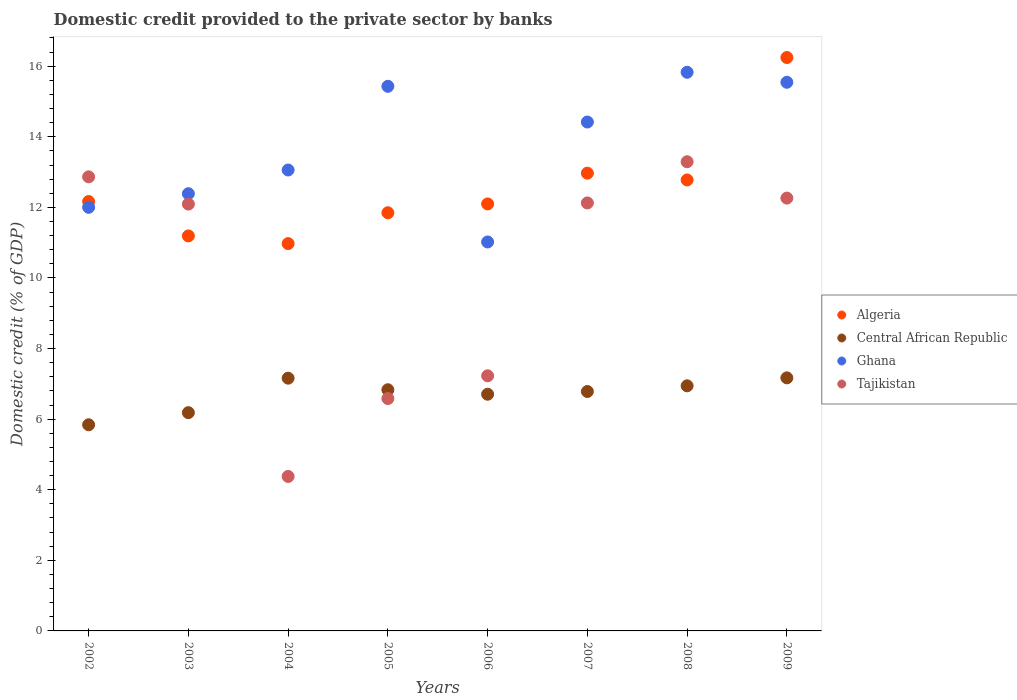What is the domestic credit provided to the private sector by banks in Algeria in 2004?
Make the answer very short. 10.97. Across all years, what is the maximum domestic credit provided to the private sector by banks in Ghana?
Your response must be concise. 15.83. Across all years, what is the minimum domestic credit provided to the private sector by banks in Tajikistan?
Your answer should be very brief. 4.38. In which year was the domestic credit provided to the private sector by banks in Algeria maximum?
Your response must be concise. 2009. In which year was the domestic credit provided to the private sector by banks in Algeria minimum?
Provide a succinct answer. 2004. What is the total domestic credit provided to the private sector by banks in Tajikistan in the graph?
Offer a terse response. 80.83. What is the difference between the domestic credit provided to the private sector by banks in Ghana in 2002 and that in 2005?
Make the answer very short. -3.43. What is the difference between the domestic credit provided to the private sector by banks in Central African Republic in 2004 and the domestic credit provided to the private sector by banks in Algeria in 2005?
Keep it short and to the point. -4.69. What is the average domestic credit provided to the private sector by banks in Algeria per year?
Offer a terse response. 12.53. In the year 2002, what is the difference between the domestic credit provided to the private sector by banks in Tajikistan and domestic credit provided to the private sector by banks in Central African Republic?
Ensure brevity in your answer.  7.02. In how many years, is the domestic credit provided to the private sector by banks in Algeria greater than 14.4 %?
Make the answer very short. 1. What is the ratio of the domestic credit provided to the private sector by banks in Tajikistan in 2007 to that in 2009?
Provide a short and direct response. 0.99. Is the difference between the domestic credit provided to the private sector by banks in Tajikistan in 2005 and 2008 greater than the difference between the domestic credit provided to the private sector by banks in Central African Republic in 2005 and 2008?
Offer a very short reply. No. What is the difference between the highest and the second highest domestic credit provided to the private sector by banks in Algeria?
Make the answer very short. 3.28. What is the difference between the highest and the lowest domestic credit provided to the private sector by banks in Ghana?
Your answer should be compact. 4.81. Is it the case that in every year, the sum of the domestic credit provided to the private sector by banks in Ghana and domestic credit provided to the private sector by banks in Tajikistan  is greater than the sum of domestic credit provided to the private sector by banks in Central African Republic and domestic credit provided to the private sector by banks in Algeria?
Offer a terse response. Yes. Is the domestic credit provided to the private sector by banks in Central African Republic strictly greater than the domestic credit provided to the private sector by banks in Tajikistan over the years?
Your answer should be compact. No. Is the domestic credit provided to the private sector by banks in Tajikistan strictly less than the domestic credit provided to the private sector by banks in Central African Republic over the years?
Ensure brevity in your answer.  No. How many years are there in the graph?
Offer a very short reply. 8. What is the difference between two consecutive major ticks on the Y-axis?
Your response must be concise. 2. Does the graph contain grids?
Offer a very short reply. No. Where does the legend appear in the graph?
Your answer should be very brief. Center right. What is the title of the graph?
Offer a very short reply. Domestic credit provided to the private sector by banks. What is the label or title of the X-axis?
Offer a very short reply. Years. What is the label or title of the Y-axis?
Ensure brevity in your answer.  Domestic credit (% of GDP). What is the Domestic credit (% of GDP) in Algeria in 2002?
Your answer should be compact. 12.17. What is the Domestic credit (% of GDP) in Central African Republic in 2002?
Ensure brevity in your answer.  5.84. What is the Domestic credit (% of GDP) in Ghana in 2002?
Your response must be concise. 12. What is the Domestic credit (% of GDP) in Tajikistan in 2002?
Provide a succinct answer. 12.86. What is the Domestic credit (% of GDP) of Algeria in 2003?
Give a very brief answer. 11.19. What is the Domestic credit (% of GDP) in Central African Republic in 2003?
Make the answer very short. 6.18. What is the Domestic credit (% of GDP) of Ghana in 2003?
Offer a terse response. 12.39. What is the Domestic credit (% of GDP) in Tajikistan in 2003?
Give a very brief answer. 12.09. What is the Domestic credit (% of GDP) of Algeria in 2004?
Make the answer very short. 10.97. What is the Domestic credit (% of GDP) in Central African Republic in 2004?
Your answer should be very brief. 7.16. What is the Domestic credit (% of GDP) in Ghana in 2004?
Offer a very short reply. 13.06. What is the Domestic credit (% of GDP) in Tajikistan in 2004?
Your answer should be very brief. 4.38. What is the Domestic credit (% of GDP) in Algeria in 2005?
Provide a short and direct response. 11.85. What is the Domestic credit (% of GDP) of Central African Republic in 2005?
Make the answer very short. 6.83. What is the Domestic credit (% of GDP) of Ghana in 2005?
Provide a short and direct response. 15.43. What is the Domestic credit (% of GDP) of Tajikistan in 2005?
Your response must be concise. 6.58. What is the Domestic credit (% of GDP) in Algeria in 2006?
Give a very brief answer. 12.1. What is the Domestic credit (% of GDP) in Central African Republic in 2006?
Offer a very short reply. 6.71. What is the Domestic credit (% of GDP) in Ghana in 2006?
Offer a terse response. 11.02. What is the Domestic credit (% of GDP) of Tajikistan in 2006?
Your response must be concise. 7.23. What is the Domestic credit (% of GDP) of Algeria in 2007?
Offer a very short reply. 12.97. What is the Domestic credit (% of GDP) in Central African Republic in 2007?
Make the answer very short. 6.78. What is the Domestic credit (% of GDP) in Ghana in 2007?
Ensure brevity in your answer.  14.42. What is the Domestic credit (% of GDP) of Tajikistan in 2007?
Keep it short and to the point. 12.13. What is the Domestic credit (% of GDP) of Algeria in 2008?
Offer a very short reply. 12.78. What is the Domestic credit (% of GDP) of Central African Republic in 2008?
Your response must be concise. 6.94. What is the Domestic credit (% of GDP) in Ghana in 2008?
Your answer should be compact. 15.83. What is the Domestic credit (% of GDP) of Tajikistan in 2008?
Your response must be concise. 13.29. What is the Domestic credit (% of GDP) of Algeria in 2009?
Keep it short and to the point. 16.25. What is the Domestic credit (% of GDP) of Central African Republic in 2009?
Keep it short and to the point. 7.17. What is the Domestic credit (% of GDP) in Ghana in 2009?
Offer a terse response. 15.54. What is the Domestic credit (% of GDP) in Tajikistan in 2009?
Keep it short and to the point. 12.26. Across all years, what is the maximum Domestic credit (% of GDP) in Algeria?
Offer a very short reply. 16.25. Across all years, what is the maximum Domestic credit (% of GDP) of Central African Republic?
Provide a short and direct response. 7.17. Across all years, what is the maximum Domestic credit (% of GDP) in Ghana?
Give a very brief answer. 15.83. Across all years, what is the maximum Domestic credit (% of GDP) in Tajikistan?
Provide a succinct answer. 13.29. Across all years, what is the minimum Domestic credit (% of GDP) of Algeria?
Make the answer very short. 10.97. Across all years, what is the minimum Domestic credit (% of GDP) in Central African Republic?
Your response must be concise. 5.84. Across all years, what is the minimum Domestic credit (% of GDP) in Ghana?
Ensure brevity in your answer.  11.02. Across all years, what is the minimum Domestic credit (% of GDP) of Tajikistan?
Make the answer very short. 4.38. What is the total Domestic credit (% of GDP) of Algeria in the graph?
Your response must be concise. 100.26. What is the total Domestic credit (% of GDP) in Central African Republic in the graph?
Make the answer very short. 53.62. What is the total Domestic credit (% of GDP) of Ghana in the graph?
Make the answer very short. 109.68. What is the total Domestic credit (% of GDP) in Tajikistan in the graph?
Your response must be concise. 80.83. What is the difference between the Domestic credit (% of GDP) in Algeria in 2002 and that in 2003?
Make the answer very short. 0.97. What is the difference between the Domestic credit (% of GDP) of Central African Republic in 2002 and that in 2003?
Offer a terse response. -0.34. What is the difference between the Domestic credit (% of GDP) of Ghana in 2002 and that in 2003?
Your answer should be compact. -0.39. What is the difference between the Domestic credit (% of GDP) in Tajikistan in 2002 and that in 2003?
Your answer should be very brief. 0.77. What is the difference between the Domestic credit (% of GDP) of Algeria in 2002 and that in 2004?
Provide a succinct answer. 1.19. What is the difference between the Domestic credit (% of GDP) of Central African Republic in 2002 and that in 2004?
Provide a short and direct response. -1.32. What is the difference between the Domestic credit (% of GDP) in Ghana in 2002 and that in 2004?
Provide a short and direct response. -1.06. What is the difference between the Domestic credit (% of GDP) of Tajikistan in 2002 and that in 2004?
Offer a terse response. 8.49. What is the difference between the Domestic credit (% of GDP) of Algeria in 2002 and that in 2005?
Keep it short and to the point. 0.32. What is the difference between the Domestic credit (% of GDP) in Central African Republic in 2002 and that in 2005?
Make the answer very short. -0.99. What is the difference between the Domestic credit (% of GDP) in Ghana in 2002 and that in 2005?
Offer a terse response. -3.43. What is the difference between the Domestic credit (% of GDP) of Tajikistan in 2002 and that in 2005?
Provide a succinct answer. 6.28. What is the difference between the Domestic credit (% of GDP) in Algeria in 2002 and that in 2006?
Make the answer very short. 0.07. What is the difference between the Domestic credit (% of GDP) in Central African Republic in 2002 and that in 2006?
Keep it short and to the point. -0.87. What is the difference between the Domestic credit (% of GDP) of Ghana in 2002 and that in 2006?
Ensure brevity in your answer.  0.98. What is the difference between the Domestic credit (% of GDP) in Tajikistan in 2002 and that in 2006?
Provide a succinct answer. 5.64. What is the difference between the Domestic credit (% of GDP) of Algeria in 2002 and that in 2007?
Provide a succinct answer. -0.8. What is the difference between the Domestic credit (% of GDP) of Central African Republic in 2002 and that in 2007?
Ensure brevity in your answer.  -0.94. What is the difference between the Domestic credit (% of GDP) in Ghana in 2002 and that in 2007?
Provide a short and direct response. -2.42. What is the difference between the Domestic credit (% of GDP) of Tajikistan in 2002 and that in 2007?
Offer a very short reply. 0.74. What is the difference between the Domestic credit (% of GDP) in Algeria in 2002 and that in 2008?
Give a very brief answer. -0.61. What is the difference between the Domestic credit (% of GDP) of Central African Republic in 2002 and that in 2008?
Give a very brief answer. -1.1. What is the difference between the Domestic credit (% of GDP) in Ghana in 2002 and that in 2008?
Give a very brief answer. -3.83. What is the difference between the Domestic credit (% of GDP) of Tajikistan in 2002 and that in 2008?
Your answer should be compact. -0.43. What is the difference between the Domestic credit (% of GDP) of Algeria in 2002 and that in 2009?
Ensure brevity in your answer.  -4.08. What is the difference between the Domestic credit (% of GDP) of Central African Republic in 2002 and that in 2009?
Offer a very short reply. -1.33. What is the difference between the Domestic credit (% of GDP) in Ghana in 2002 and that in 2009?
Provide a short and direct response. -3.54. What is the difference between the Domestic credit (% of GDP) of Tajikistan in 2002 and that in 2009?
Keep it short and to the point. 0.6. What is the difference between the Domestic credit (% of GDP) in Algeria in 2003 and that in 2004?
Provide a short and direct response. 0.22. What is the difference between the Domestic credit (% of GDP) of Central African Republic in 2003 and that in 2004?
Make the answer very short. -0.98. What is the difference between the Domestic credit (% of GDP) of Ghana in 2003 and that in 2004?
Offer a terse response. -0.67. What is the difference between the Domestic credit (% of GDP) in Tajikistan in 2003 and that in 2004?
Make the answer very short. 7.72. What is the difference between the Domestic credit (% of GDP) in Algeria in 2003 and that in 2005?
Offer a very short reply. -0.66. What is the difference between the Domestic credit (% of GDP) in Central African Republic in 2003 and that in 2005?
Your answer should be very brief. -0.65. What is the difference between the Domestic credit (% of GDP) of Ghana in 2003 and that in 2005?
Ensure brevity in your answer.  -3.04. What is the difference between the Domestic credit (% of GDP) of Tajikistan in 2003 and that in 2005?
Your response must be concise. 5.51. What is the difference between the Domestic credit (% of GDP) of Algeria in 2003 and that in 2006?
Provide a succinct answer. -0.91. What is the difference between the Domestic credit (% of GDP) in Central African Republic in 2003 and that in 2006?
Offer a very short reply. -0.52. What is the difference between the Domestic credit (% of GDP) of Ghana in 2003 and that in 2006?
Make the answer very short. 1.37. What is the difference between the Domestic credit (% of GDP) of Tajikistan in 2003 and that in 2006?
Provide a succinct answer. 4.87. What is the difference between the Domestic credit (% of GDP) of Algeria in 2003 and that in 2007?
Provide a succinct answer. -1.78. What is the difference between the Domestic credit (% of GDP) in Central African Republic in 2003 and that in 2007?
Ensure brevity in your answer.  -0.6. What is the difference between the Domestic credit (% of GDP) of Ghana in 2003 and that in 2007?
Give a very brief answer. -2.03. What is the difference between the Domestic credit (% of GDP) of Tajikistan in 2003 and that in 2007?
Your answer should be compact. -0.03. What is the difference between the Domestic credit (% of GDP) in Algeria in 2003 and that in 2008?
Your answer should be very brief. -1.59. What is the difference between the Domestic credit (% of GDP) of Central African Republic in 2003 and that in 2008?
Your response must be concise. -0.76. What is the difference between the Domestic credit (% of GDP) of Ghana in 2003 and that in 2008?
Provide a short and direct response. -3.44. What is the difference between the Domestic credit (% of GDP) of Tajikistan in 2003 and that in 2008?
Your answer should be compact. -1.2. What is the difference between the Domestic credit (% of GDP) in Algeria in 2003 and that in 2009?
Ensure brevity in your answer.  -5.05. What is the difference between the Domestic credit (% of GDP) of Central African Republic in 2003 and that in 2009?
Offer a terse response. -0.99. What is the difference between the Domestic credit (% of GDP) in Ghana in 2003 and that in 2009?
Provide a short and direct response. -3.16. What is the difference between the Domestic credit (% of GDP) in Tajikistan in 2003 and that in 2009?
Give a very brief answer. -0.17. What is the difference between the Domestic credit (% of GDP) in Algeria in 2004 and that in 2005?
Ensure brevity in your answer.  -0.87. What is the difference between the Domestic credit (% of GDP) of Central African Republic in 2004 and that in 2005?
Make the answer very short. 0.33. What is the difference between the Domestic credit (% of GDP) of Ghana in 2004 and that in 2005?
Make the answer very short. -2.37. What is the difference between the Domestic credit (% of GDP) of Tajikistan in 2004 and that in 2005?
Your answer should be very brief. -2.21. What is the difference between the Domestic credit (% of GDP) of Algeria in 2004 and that in 2006?
Your answer should be compact. -1.12. What is the difference between the Domestic credit (% of GDP) in Central African Republic in 2004 and that in 2006?
Your answer should be compact. 0.45. What is the difference between the Domestic credit (% of GDP) of Ghana in 2004 and that in 2006?
Keep it short and to the point. 2.04. What is the difference between the Domestic credit (% of GDP) of Tajikistan in 2004 and that in 2006?
Ensure brevity in your answer.  -2.85. What is the difference between the Domestic credit (% of GDP) of Algeria in 2004 and that in 2007?
Your answer should be compact. -2. What is the difference between the Domestic credit (% of GDP) of Central African Republic in 2004 and that in 2007?
Keep it short and to the point. 0.38. What is the difference between the Domestic credit (% of GDP) of Ghana in 2004 and that in 2007?
Your answer should be very brief. -1.36. What is the difference between the Domestic credit (% of GDP) of Tajikistan in 2004 and that in 2007?
Offer a very short reply. -7.75. What is the difference between the Domestic credit (% of GDP) of Algeria in 2004 and that in 2008?
Ensure brevity in your answer.  -1.8. What is the difference between the Domestic credit (% of GDP) of Central African Republic in 2004 and that in 2008?
Make the answer very short. 0.22. What is the difference between the Domestic credit (% of GDP) of Ghana in 2004 and that in 2008?
Give a very brief answer. -2.77. What is the difference between the Domestic credit (% of GDP) of Tajikistan in 2004 and that in 2008?
Keep it short and to the point. -8.92. What is the difference between the Domestic credit (% of GDP) in Algeria in 2004 and that in 2009?
Offer a very short reply. -5.27. What is the difference between the Domestic credit (% of GDP) of Central African Republic in 2004 and that in 2009?
Provide a succinct answer. -0.01. What is the difference between the Domestic credit (% of GDP) in Ghana in 2004 and that in 2009?
Offer a very short reply. -2.49. What is the difference between the Domestic credit (% of GDP) of Tajikistan in 2004 and that in 2009?
Offer a very short reply. -7.89. What is the difference between the Domestic credit (% of GDP) of Algeria in 2005 and that in 2006?
Keep it short and to the point. -0.25. What is the difference between the Domestic credit (% of GDP) of Central African Republic in 2005 and that in 2006?
Your answer should be very brief. 0.13. What is the difference between the Domestic credit (% of GDP) in Ghana in 2005 and that in 2006?
Give a very brief answer. 4.41. What is the difference between the Domestic credit (% of GDP) in Tajikistan in 2005 and that in 2006?
Your answer should be very brief. -0.64. What is the difference between the Domestic credit (% of GDP) in Algeria in 2005 and that in 2007?
Your answer should be compact. -1.12. What is the difference between the Domestic credit (% of GDP) of Central African Republic in 2005 and that in 2007?
Your response must be concise. 0.05. What is the difference between the Domestic credit (% of GDP) in Ghana in 2005 and that in 2007?
Ensure brevity in your answer.  1.01. What is the difference between the Domestic credit (% of GDP) in Tajikistan in 2005 and that in 2007?
Give a very brief answer. -5.54. What is the difference between the Domestic credit (% of GDP) in Algeria in 2005 and that in 2008?
Offer a very short reply. -0.93. What is the difference between the Domestic credit (% of GDP) in Central African Republic in 2005 and that in 2008?
Give a very brief answer. -0.11. What is the difference between the Domestic credit (% of GDP) of Ghana in 2005 and that in 2008?
Offer a very short reply. -0.4. What is the difference between the Domestic credit (% of GDP) of Tajikistan in 2005 and that in 2008?
Give a very brief answer. -6.71. What is the difference between the Domestic credit (% of GDP) of Algeria in 2005 and that in 2009?
Your response must be concise. -4.4. What is the difference between the Domestic credit (% of GDP) of Central African Republic in 2005 and that in 2009?
Your answer should be compact. -0.34. What is the difference between the Domestic credit (% of GDP) of Ghana in 2005 and that in 2009?
Ensure brevity in your answer.  -0.11. What is the difference between the Domestic credit (% of GDP) of Tajikistan in 2005 and that in 2009?
Keep it short and to the point. -5.68. What is the difference between the Domestic credit (% of GDP) in Algeria in 2006 and that in 2007?
Your answer should be compact. -0.87. What is the difference between the Domestic credit (% of GDP) in Central African Republic in 2006 and that in 2007?
Your answer should be very brief. -0.08. What is the difference between the Domestic credit (% of GDP) of Ghana in 2006 and that in 2007?
Make the answer very short. -3.4. What is the difference between the Domestic credit (% of GDP) of Tajikistan in 2006 and that in 2007?
Keep it short and to the point. -4.9. What is the difference between the Domestic credit (% of GDP) of Algeria in 2006 and that in 2008?
Your answer should be very brief. -0.68. What is the difference between the Domestic credit (% of GDP) of Central African Republic in 2006 and that in 2008?
Provide a short and direct response. -0.24. What is the difference between the Domestic credit (% of GDP) of Ghana in 2006 and that in 2008?
Your answer should be very brief. -4.81. What is the difference between the Domestic credit (% of GDP) of Tajikistan in 2006 and that in 2008?
Your response must be concise. -6.07. What is the difference between the Domestic credit (% of GDP) in Algeria in 2006 and that in 2009?
Your answer should be compact. -4.15. What is the difference between the Domestic credit (% of GDP) of Central African Republic in 2006 and that in 2009?
Offer a very short reply. -0.46. What is the difference between the Domestic credit (% of GDP) of Ghana in 2006 and that in 2009?
Provide a short and direct response. -4.52. What is the difference between the Domestic credit (% of GDP) in Tajikistan in 2006 and that in 2009?
Your answer should be very brief. -5.04. What is the difference between the Domestic credit (% of GDP) of Algeria in 2007 and that in 2008?
Your response must be concise. 0.19. What is the difference between the Domestic credit (% of GDP) in Central African Republic in 2007 and that in 2008?
Your response must be concise. -0.16. What is the difference between the Domestic credit (% of GDP) of Ghana in 2007 and that in 2008?
Provide a succinct answer. -1.41. What is the difference between the Domestic credit (% of GDP) of Tajikistan in 2007 and that in 2008?
Ensure brevity in your answer.  -1.17. What is the difference between the Domestic credit (% of GDP) in Algeria in 2007 and that in 2009?
Offer a terse response. -3.28. What is the difference between the Domestic credit (% of GDP) of Central African Republic in 2007 and that in 2009?
Provide a short and direct response. -0.39. What is the difference between the Domestic credit (% of GDP) of Ghana in 2007 and that in 2009?
Offer a terse response. -1.13. What is the difference between the Domestic credit (% of GDP) of Tajikistan in 2007 and that in 2009?
Give a very brief answer. -0.14. What is the difference between the Domestic credit (% of GDP) of Algeria in 2008 and that in 2009?
Your response must be concise. -3.47. What is the difference between the Domestic credit (% of GDP) in Central African Republic in 2008 and that in 2009?
Your answer should be very brief. -0.23. What is the difference between the Domestic credit (% of GDP) of Ghana in 2008 and that in 2009?
Offer a very short reply. 0.28. What is the difference between the Domestic credit (% of GDP) of Tajikistan in 2008 and that in 2009?
Give a very brief answer. 1.03. What is the difference between the Domestic credit (% of GDP) in Algeria in 2002 and the Domestic credit (% of GDP) in Central African Republic in 2003?
Make the answer very short. 5.98. What is the difference between the Domestic credit (% of GDP) in Algeria in 2002 and the Domestic credit (% of GDP) in Ghana in 2003?
Offer a very short reply. -0.22. What is the difference between the Domestic credit (% of GDP) in Algeria in 2002 and the Domestic credit (% of GDP) in Tajikistan in 2003?
Make the answer very short. 0.07. What is the difference between the Domestic credit (% of GDP) in Central African Republic in 2002 and the Domestic credit (% of GDP) in Ghana in 2003?
Offer a terse response. -6.55. What is the difference between the Domestic credit (% of GDP) of Central African Republic in 2002 and the Domestic credit (% of GDP) of Tajikistan in 2003?
Provide a succinct answer. -6.25. What is the difference between the Domestic credit (% of GDP) in Ghana in 2002 and the Domestic credit (% of GDP) in Tajikistan in 2003?
Provide a succinct answer. -0.09. What is the difference between the Domestic credit (% of GDP) in Algeria in 2002 and the Domestic credit (% of GDP) in Central African Republic in 2004?
Make the answer very short. 5. What is the difference between the Domestic credit (% of GDP) in Algeria in 2002 and the Domestic credit (% of GDP) in Ghana in 2004?
Ensure brevity in your answer.  -0.89. What is the difference between the Domestic credit (% of GDP) of Algeria in 2002 and the Domestic credit (% of GDP) of Tajikistan in 2004?
Provide a succinct answer. 7.79. What is the difference between the Domestic credit (% of GDP) of Central African Republic in 2002 and the Domestic credit (% of GDP) of Ghana in 2004?
Offer a very short reply. -7.22. What is the difference between the Domestic credit (% of GDP) in Central African Republic in 2002 and the Domestic credit (% of GDP) in Tajikistan in 2004?
Provide a short and direct response. 1.46. What is the difference between the Domestic credit (% of GDP) of Ghana in 2002 and the Domestic credit (% of GDP) of Tajikistan in 2004?
Your answer should be compact. 7.62. What is the difference between the Domestic credit (% of GDP) of Algeria in 2002 and the Domestic credit (% of GDP) of Central African Republic in 2005?
Your answer should be compact. 5.33. What is the difference between the Domestic credit (% of GDP) of Algeria in 2002 and the Domestic credit (% of GDP) of Ghana in 2005?
Keep it short and to the point. -3.26. What is the difference between the Domestic credit (% of GDP) of Algeria in 2002 and the Domestic credit (% of GDP) of Tajikistan in 2005?
Your response must be concise. 5.58. What is the difference between the Domestic credit (% of GDP) in Central African Republic in 2002 and the Domestic credit (% of GDP) in Ghana in 2005?
Offer a terse response. -9.59. What is the difference between the Domestic credit (% of GDP) in Central African Republic in 2002 and the Domestic credit (% of GDP) in Tajikistan in 2005?
Provide a succinct answer. -0.74. What is the difference between the Domestic credit (% of GDP) of Ghana in 2002 and the Domestic credit (% of GDP) of Tajikistan in 2005?
Keep it short and to the point. 5.42. What is the difference between the Domestic credit (% of GDP) of Algeria in 2002 and the Domestic credit (% of GDP) of Central African Republic in 2006?
Your answer should be compact. 5.46. What is the difference between the Domestic credit (% of GDP) of Algeria in 2002 and the Domestic credit (% of GDP) of Ghana in 2006?
Offer a very short reply. 1.15. What is the difference between the Domestic credit (% of GDP) in Algeria in 2002 and the Domestic credit (% of GDP) in Tajikistan in 2006?
Your response must be concise. 4.94. What is the difference between the Domestic credit (% of GDP) in Central African Republic in 2002 and the Domestic credit (% of GDP) in Ghana in 2006?
Your answer should be very brief. -5.18. What is the difference between the Domestic credit (% of GDP) of Central African Republic in 2002 and the Domestic credit (% of GDP) of Tajikistan in 2006?
Your answer should be very brief. -1.39. What is the difference between the Domestic credit (% of GDP) in Ghana in 2002 and the Domestic credit (% of GDP) in Tajikistan in 2006?
Make the answer very short. 4.77. What is the difference between the Domestic credit (% of GDP) in Algeria in 2002 and the Domestic credit (% of GDP) in Central African Republic in 2007?
Your response must be concise. 5.38. What is the difference between the Domestic credit (% of GDP) of Algeria in 2002 and the Domestic credit (% of GDP) of Ghana in 2007?
Offer a very short reply. -2.25. What is the difference between the Domestic credit (% of GDP) of Algeria in 2002 and the Domestic credit (% of GDP) of Tajikistan in 2007?
Provide a succinct answer. 0.04. What is the difference between the Domestic credit (% of GDP) in Central African Republic in 2002 and the Domestic credit (% of GDP) in Ghana in 2007?
Offer a terse response. -8.58. What is the difference between the Domestic credit (% of GDP) of Central African Republic in 2002 and the Domestic credit (% of GDP) of Tajikistan in 2007?
Your answer should be very brief. -6.28. What is the difference between the Domestic credit (% of GDP) of Ghana in 2002 and the Domestic credit (% of GDP) of Tajikistan in 2007?
Give a very brief answer. -0.12. What is the difference between the Domestic credit (% of GDP) in Algeria in 2002 and the Domestic credit (% of GDP) in Central African Republic in 2008?
Provide a short and direct response. 5.22. What is the difference between the Domestic credit (% of GDP) of Algeria in 2002 and the Domestic credit (% of GDP) of Ghana in 2008?
Give a very brief answer. -3.66. What is the difference between the Domestic credit (% of GDP) in Algeria in 2002 and the Domestic credit (% of GDP) in Tajikistan in 2008?
Ensure brevity in your answer.  -1.13. What is the difference between the Domestic credit (% of GDP) in Central African Republic in 2002 and the Domestic credit (% of GDP) in Ghana in 2008?
Your response must be concise. -9.99. What is the difference between the Domestic credit (% of GDP) of Central African Republic in 2002 and the Domestic credit (% of GDP) of Tajikistan in 2008?
Your response must be concise. -7.45. What is the difference between the Domestic credit (% of GDP) of Ghana in 2002 and the Domestic credit (% of GDP) of Tajikistan in 2008?
Offer a very short reply. -1.29. What is the difference between the Domestic credit (% of GDP) of Algeria in 2002 and the Domestic credit (% of GDP) of Central African Republic in 2009?
Offer a terse response. 5. What is the difference between the Domestic credit (% of GDP) in Algeria in 2002 and the Domestic credit (% of GDP) in Ghana in 2009?
Provide a succinct answer. -3.38. What is the difference between the Domestic credit (% of GDP) of Algeria in 2002 and the Domestic credit (% of GDP) of Tajikistan in 2009?
Provide a succinct answer. -0.1. What is the difference between the Domestic credit (% of GDP) of Central African Republic in 2002 and the Domestic credit (% of GDP) of Ghana in 2009?
Ensure brevity in your answer.  -9.7. What is the difference between the Domestic credit (% of GDP) in Central African Republic in 2002 and the Domestic credit (% of GDP) in Tajikistan in 2009?
Ensure brevity in your answer.  -6.42. What is the difference between the Domestic credit (% of GDP) in Ghana in 2002 and the Domestic credit (% of GDP) in Tajikistan in 2009?
Your answer should be very brief. -0.26. What is the difference between the Domestic credit (% of GDP) of Algeria in 2003 and the Domestic credit (% of GDP) of Central African Republic in 2004?
Offer a very short reply. 4.03. What is the difference between the Domestic credit (% of GDP) of Algeria in 2003 and the Domestic credit (% of GDP) of Ghana in 2004?
Give a very brief answer. -1.87. What is the difference between the Domestic credit (% of GDP) of Algeria in 2003 and the Domestic credit (% of GDP) of Tajikistan in 2004?
Your answer should be very brief. 6.81. What is the difference between the Domestic credit (% of GDP) in Central African Republic in 2003 and the Domestic credit (% of GDP) in Ghana in 2004?
Your response must be concise. -6.87. What is the difference between the Domestic credit (% of GDP) of Central African Republic in 2003 and the Domestic credit (% of GDP) of Tajikistan in 2004?
Your answer should be compact. 1.81. What is the difference between the Domestic credit (% of GDP) in Ghana in 2003 and the Domestic credit (% of GDP) in Tajikistan in 2004?
Make the answer very short. 8.01. What is the difference between the Domestic credit (% of GDP) of Algeria in 2003 and the Domestic credit (% of GDP) of Central African Republic in 2005?
Provide a short and direct response. 4.36. What is the difference between the Domestic credit (% of GDP) in Algeria in 2003 and the Domestic credit (% of GDP) in Ghana in 2005?
Keep it short and to the point. -4.24. What is the difference between the Domestic credit (% of GDP) of Algeria in 2003 and the Domestic credit (% of GDP) of Tajikistan in 2005?
Give a very brief answer. 4.61. What is the difference between the Domestic credit (% of GDP) of Central African Republic in 2003 and the Domestic credit (% of GDP) of Ghana in 2005?
Provide a succinct answer. -9.25. What is the difference between the Domestic credit (% of GDP) in Central African Republic in 2003 and the Domestic credit (% of GDP) in Tajikistan in 2005?
Ensure brevity in your answer.  -0.4. What is the difference between the Domestic credit (% of GDP) of Ghana in 2003 and the Domestic credit (% of GDP) of Tajikistan in 2005?
Your response must be concise. 5.8. What is the difference between the Domestic credit (% of GDP) in Algeria in 2003 and the Domestic credit (% of GDP) in Central African Republic in 2006?
Ensure brevity in your answer.  4.49. What is the difference between the Domestic credit (% of GDP) of Algeria in 2003 and the Domestic credit (% of GDP) of Ghana in 2006?
Keep it short and to the point. 0.17. What is the difference between the Domestic credit (% of GDP) in Algeria in 2003 and the Domestic credit (% of GDP) in Tajikistan in 2006?
Offer a terse response. 3.96. What is the difference between the Domestic credit (% of GDP) in Central African Republic in 2003 and the Domestic credit (% of GDP) in Ghana in 2006?
Your answer should be very brief. -4.84. What is the difference between the Domestic credit (% of GDP) in Central African Republic in 2003 and the Domestic credit (% of GDP) in Tajikistan in 2006?
Offer a terse response. -1.04. What is the difference between the Domestic credit (% of GDP) of Ghana in 2003 and the Domestic credit (% of GDP) of Tajikistan in 2006?
Give a very brief answer. 5.16. What is the difference between the Domestic credit (% of GDP) of Algeria in 2003 and the Domestic credit (% of GDP) of Central African Republic in 2007?
Offer a very short reply. 4.41. What is the difference between the Domestic credit (% of GDP) in Algeria in 2003 and the Domestic credit (% of GDP) in Ghana in 2007?
Your answer should be compact. -3.23. What is the difference between the Domestic credit (% of GDP) in Algeria in 2003 and the Domestic credit (% of GDP) in Tajikistan in 2007?
Ensure brevity in your answer.  -0.93. What is the difference between the Domestic credit (% of GDP) in Central African Republic in 2003 and the Domestic credit (% of GDP) in Ghana in 2007?
Keep it short and to the point. -8.23. What is the difference between the Domestic credit (% of GDP) of Central African Republic in 2003 and the Domestic credit (% of GDP) of Tajikistan in 2007?
Make the answer very short. -5.94. What is the difference between the Domestic credit (% of GDP) of Ghana in 2003 and the Domestic credit (% of GDP) of Tajikistan in 2007?
Provide a succinct answer. 0.26. What is the difference between the Domestic credit (% of GDP) of Algeria in 2003 and the Domestic credit (% of GDP) of Central African Republic in 2008?
Your answer should be compact. 4.25. What is the difference between the Domestic credit (% of GDP) of Algeria in 2003 and the Domestic credit (% of GDP) of Ghana in 2008?
Your answer should be compact. -4.64. What is the difference between the Domestic credit (% of GDP) of Algeria in 2003 and the Domestic credit (% of GDP) of Tajikistan in 2008?
Make the answer very short. -2.1. What is the difference between the Domestic credit (% of GDP) in Central African Republic in 2003 and the Domestic credit (% of GDP) in Ghana in 2008?
Provide a short and direct response. -9.64. What is the difference between the Domestic credit (% of GDP) of Central African Republic in 2003 and the Domestic credit (% of GDP) of Tajikistan in 2008?
Offer a very short reply. -7.11. What is the difference between the Domestic credit (% of GDP) of Ghana in 2003 and the Domestic credit (% of GDP) of Tajikistan in 2008?
Keep it short and to the point. -0.91. What is the difference between the Domestic credit (% of GDP) of Algeria in 2003 and the Domestic credit (% of GDP) of Central African Republic in 2009?
Keep it short and to the point. 4.02. What is the difference between the Domestic credit (% of GDP) of Algeria in 2003 and the Domestic credit (% of GDP) of Ghana in 2009?
Provide a succinct answer. -4.35. What is the difference between the Domestic credit (% of GDP) of Algeria in 2003 and the Domestic credit (% of GDP) of Tajikistan in 2009?
Give a very brief answer. -1.07. What is the difference between the Domestic credit (% of GDP) in Central African Republic in 2003 and the Domestic credit (% of GDP) in Ghana in 2009?
Offer a terse response. -9.36. What is the difference between the Domestic credit (% of GDP) in Central African Republic in 2003 and the Domestic credit (% of GDP) in Tajikistan in 2009?
Ensure brevity in your answer.  -6.08. What is the difference between the Domestic credit (% of GDP) in Ghana in 2003 and the Domestic credit (% of GDP) in Tajikistan in 2009?
Keep it short and to the point. 0.12. What is the difference between the Domestic credit (% of GDP) in Algeria in 2004 and the Domestic credit (% of GDP) in Central African Republic in 2005?
Provide a short and direct response. 4.14. What is the difference between the Domestic credit (% of GDP) in Algeria in 2004 and the Domestic credit (% of GDP) in Ghana in 2005?
Keep it short and to the point. -4.46. What is the difference between the Domestic credit (% of GDP) in Algeria in 2004 and the Domestic credit (% of GDP) in Tajikistan in 2005?
Offer a terse response. 4.39. What is the difference between the Domestic credit (% of GDP) in Central African Republic in 2004 and the Domestic credit (% of GDP) in Ghana in 2005?
Keep it short and to the point. -8.27. What is the difference between the Domestic credit (% of GDP) of Central African Republic in 2004 and the Domestic credit (% of GDP) of Tajikistan in 2005?
Make the answer very short. 0.58. What is the difference between the Domestic credit (% of GDP) of Ghana in 2004 and the Domestic credit (% of GDP) of Tajikistan in 2005?
Provide a succinct answer. 6.47. What is the difference between the Domestic credit (% of GDP) in Algeria in 2004 and the Domestic credit (% of GDP) in Central African Republic in 2006?
Your answer should be very brief. 4.27. What is the difference between the Domestic credit (% of GDP) in Algeria in 2004 and the Domestic credit (% of GDP) in Ghana in 2006?
Your response must be concise. -0.05. What is the difference between the Domestic credit (% of GDP) in Algeria in 2004 and the Domestic credit (% of GDP) in Tajikistan in 2006?
Your answer should be compact. 3.75. What is the difference between the Domestic credit (% of GDP) of Central African Republic in 2004 and the Domestic credit (% of GDP) of Ghana in 2006?
Give a very brief answer. -3.86. What is the difference between the Domestic credit (% of GDP) of Central African Republic in 2004 and the Domestic credit (% of GDP) of Tajikistan in 2006?
Make the answer very short. -0.07. What is the difference between the Domestic credit (% of GDP) of Ghana in 2004 and the Domestic credit (% of GDP) of Tajikistan in 2006?
Ensure brevity in your answer.  5.83. What is the difference between the Domestic credit (% of GDP) in Algeria in 2004 and the Domestic credit (% of GDP) in Central African Republic in 2007?
Ensure brevity in your answer.  4.19. What is the difference between the Domestic credit (% of GDP) of Algeria in 2004 and the Domestic credit (% of GDP) of Ghana in 2007?
Provide a succinct answer. -3.44. What is the difference between the Domestic credit (% of GDP) in Algeria in 2004 and the Domestic credit (% of GDP) in Tajikistan in 2007?
Your response must be concise. -1.15. What is the difference between the Domestic credit (% of GDP) in Central African Republic in 2004 and the Domestic credit (% of GDP) in Ghana in 2007?
Make the answer very short. -7.26. What is the difference between the Domestic credit (% of GDP) of Central African Republic in 2004 and the Domestic credit (% of GDP) of Tajikistan in 2007?
Give a very brief answer. -4.96. What is the difference between the Domestic credit (% of GDP) of Ghana in 2004 and the Domestic credit (% of GDP) of Tajikistan in 2007?
Give a very brief answer. 0.93. What is the difference between the Domestic credit (% of GDP) in Algeria in 2004 and the Domestic credit (% of GDP) in Central African Republic in 2008?
Offer a terse response. 4.03. What is the difference between the Domestic credit (% of GDP) in Algeria in 2004 and the Domestic credit (% of GDP) in Ghana in 2008?
Offer a very short reply. -4.85. What is the difference between the Domestic credit (% of GDP) in Algeria in 2004 and the Domestic credit (% of GDP) in Tajikistan in 2008?
Provide a short and direct response. -2.32. What is the difference between the Domestic credit (% of GDP) of Central African Republic in 2004 and the Domestic credit (% of GDP) of Ghana in 2008?
Your response must be concise. -8.67. What is the difference between the Domestic credit (% of GDP) of Central African Republic in 2004 and the Domestic credit (% of GDP) of Tajikistan in 2008?
Your answer should be very brief. -6.13. What is the difference between the Domestic credit (% of GDP) in Ghana in 2004 and the Domestic credit (% of GDP) in Tajikistan in 2008?
Offer a terse response. -0.23. What is the difference between the Domestic credit (% of GDP) of Algeria in 2004 and the Domestic credit (% of GDP) of Central African Republic in 2009?
Give a very brief answer. 3.8. What is the difference between the Domestic credit (% of GDP) of Algeria in 2004 and the Domestic credit (% of GDP) of Ghana in 2009?
Offer a terse response. -4.57. What is the difference between the Domestic credit (% of GDP) in Algeria in 2004 and the Domestic credit (% of GDP) in Tajikistan in 2009?
Your answer should be compact. -1.29. What is the difference between the Domestic credit (% of GDP) of Central African Republic in 2004 and the Domestic credit (% of GDP) of Ghana in 2009?
Offer a terse response. -8.38. What is the difference between the Domestic credit (% of GDP) of Central African Republic in 2004 and the Domestic credit (% of GDP) of Tajikistan in 2009?
Give a very brief answer. -5.1. What is the difference between the Domestic credit (% of GDP) of Ghana in 2004 and the Domestic credit (% of GDP) of Tajikistan in 2009?
Offer a very short reply. 0.8. What is the difference between the Domestic credit (% of GDP) in Algeria in 2005 and the Domestic credit (% of GDP) in Central African Republic in 2006?
Provide a short and direct response. 5.14. What is the difference between the Domestic credit (% of GDP) of Algeria in 2005 and the Domestic credit (% of GDP) of Ghana in 2006?
Your answer should be compact. 0.83. What is the difference between the Domestic credit (% of GDP) of Algeria in 2005 and the Domestic credit (% of GDP) of Tajikistan in 2006?
Provide a succinct answer. 4.62. What is the difference between the Domestic credit (% of GDP) of Central African Republic in 2005 and the Domestic credit (% of GDP) of Ghana in 2006?
Offer a very short reply. -4.19. What is the difference between the Domestic credit (% of GDP) of Central African Republic in 2005 and the Domestic credit (% of GDP) of Tajikistan in 2006?
Offer a terse response. -0.39. What is the difference between the Domestic credit (% of GDP) in Ghana in 2005 and the Domestic credit (% of GDP) in Tajikistan in 2006?
Ensure brevity in your answer.  8.2. What is the difference between the Domestic credit (% of GDP) in Algeria in 2005 and the Domestic credit (% of GDP) in Central African Republic in 2007?
Keep it short and to the point. 5.06. What is the difference between the Domestic credit (% of GDP) of Algeria in 2005 and the Domestic credit (% of GDP) of Ghana in 2007?
Give a very brief answer. -2.57. What is the difference between the Domestic credit (% of GDP) in Algeria in 2005 and the Domestic credit (% of GDP) in Tajikistan in 2007?
Provide a succinct answer. -0.28. What is the difference between the Domestic credit (% of GDP) of Central African Republic in 2005 and the Domestic credit (% of GDP) of Ghana in 2007?
Keep it short and to the point. -7.58. What is the difference between the Domestic credit (% of GDP) in Central African Republic in 2005 and the Domestic credit (% of GDP) in Tajikistan in 2007?
Your answer should be very brief. -5.29. What is the difference between the Domestic credit (% of GDP) of Ghana in 2005 and the Domestic credit (% of GDP) of Tajikistan in 2007?
Your response must be concise. 3.3. What is the difference between the Domestic credit (% of GDP) in Algeria in 2005 and the Domestic credit (% of GDP) in Central African Republic in 2008?
Your answer should be compact. 4.9. What is the difference between the Domestic credit (% of GDP) in Algeria in 2005 and the Domestic credit (% of GDP) in Ghana in 2008?
Provide a short and direct response. -3.98. What is the difference between the Domestic credit (% of GDP) of Algeria in 2005 and the Domestic credit (% of GDP) of Tajikistan in 2008?
Ensure brevity in your answer.  -1.45. What is the difference between the Domestic credit (% of GDP) of Central African Republic in 2005 and the Domestic credit (% of GDP) of Ghana in 2008?
Keep it short and to the point. -8.99. What is the difference between the Domestic credit (% of GDP) in Central African Republic in 2005 and the Domestic credit (% of GDP) in Tajikistan in 2008?
Ensure brevity in your answer.  -6.46. What is the difference between the Domestic credit (% of GDP) in Ghana in 2005 and the Domestic credit (% of GDP) in Tajikistan in 2008?
Give a very brief answer. 2.14. What is the difference between the Domestic credit (% of GDP) in Algeria in 2005 and the Domestic credit (% of GDP) in Central African Republic in 2009?
Your answer should be compact. 4.68. What is the difference between the Domestic credit (% of GDP) in Algeria in 2005 and the Domestic credit (% of GDP) in Ghana in 2009?
Your answer should be compact. -3.7. What is the difference between the Domestic credit (% of GDP) of Algeria in 2005 and the Domestic credit (% of GDP) of Tajikistan in 2009?
Offer a very short reply. -0.42. What is the difference between the Domestic credit (% of GDP) in Central African Republic in 2005 and the Domestic credit (% of GDP) in Ghana in 2009?
Offer a terse response. -8.71. What is the difference between the Domestic credit (% of GDP) in Central African Republic in 2005 and the Domestic credit (% of GDP) in Tajikistan in 2009?
Offer a very short reply. -5.43. What is the difference between the Domestic credit (% of GDP) of Ghana in 2005 and the Domestic credit (% of GDP) of Tajikistan in 2009?
Your response must be concise. 3.17. What is the difference between the Domestic credit (% of GDP) of Algeria in 2006 and the Domestic credit (% of GDP) of Central African Republic in 2007?
Offer a terse response. 5.31. What is the difference between the Domestic credit (% of GDP) of Algeria in 2006 and the Domestic credit (% of GDP) of Ghana in 2007?
Provide a short and direct response. -2.32. What is the difference between the Domestic credit (% of GDP) in Algeria in 2006 and the Domestic credit (% of GDP) in Tajikistan in 2007?
Keep it short and to the point. -0.03. What is the difference between the Domestic credit (% of GDP) of Central African Republic in 2006 and the Domestic credit (% of GDP) of Ghana in 2007?
Your answer should be very brief. -7.71. What is the difference between the Domestic credit (% of GDP) of Central African Republic in 2006 and the Domestic credit (% of GDP) of Tajikistan in 2007?
Provide a short and direct response. -5.42. What is the difference between the Domestic credit (% of GDP) in Ghana in 2006 and the Domestic credit (% of GDP) in Tajikistan in 2007?
Offer a terse response. -1.11. What is the difference between the Domestic credit (% of GDP) of Algeria in 2006 and the Domestic credit (% of GDP) of Central African Republic in 2008?
Offer a very short reply. 5.15. What is the difference between the Domestic credit (% of GDP) in Algeria in 2006 and the Domestic credit (% of GDP) in Ghana in 2008?
Your answer should be compact. -3.73. What is the difference between the Domestic credit (% of GDP) in Algeria in 2006 and the Domestic credit (% of GDP) in Tajikistan in 2008?
Offer a very short reply. -1.2. What is the difference between the Domestic credit (% of GDP) of Central African Republic in 2006 and the Domestic credit (% of GDP) of Ghana in 2008?
Offer a very short reply. -9.12. What is the difference between the Domestic credit (% of GDP) of Central African Republic in 2006 and the Domestic credit (% of GDP) of Tajikistan in 2008?
Keep it short and to the point. -6.59. What is the difference between the Domestic credit (% of GDP) of Ghana in 2006 and the Domestic credit (% of GDP) of Tajikistan in 2008?
Offer a very short reply. -2.27. What is the difference between the Domestic credit (% of GDP) of Algeria in 2006 and the Domestic credit (% of GDP) of Central African Republic in 2009?
Make the answer very short. 4.93. What is the difference between the Domestic credit (% of GDP) of Algeria in 2006 and the Domestic credit (% of GDP) of Ghana in 2009?
Provide a succinct answer. -3.45. What is the difference between the Domestic credit (% of GDP) in Algeria in 2006 and the Domestic credit (% of GDP) in Tajikistan in 2009?
Your answer should be very brief. -0.17. What is the difference between the Domestic credit (% of GDP) of Central African Republic in 2006 and the Domestic credit (% of GDP) of Ghana in 2009?
Your response must be concise. -8.84. What is the difference between the Domestic credit (% of GDP) in Central African Republic in 2006 and the Domestic credit (% of GDP) in Tajikistan in 2009?
Provide a short and direct response. -5.56. What is the difference between the Domestic credit (% of GDP) of Ghana in 2006 and the Domestic credit (% of GDP) of Tajikistan in 2009?
Keep it short and to the point. -1.24. What is the difference between the Domestic credit (% of GDP) of Algeria in 2007 and the Domestic credit (% of GDP) of Central African Republic in 2008?
Your response must be concise. 6.02. What is the difference between the Domestic credit (% of GDP) of Algeria in 2007 and the Domestic credit (% of GDP) of Ghana in 2008?
Ensure brevity in your answer.  -2.86. What is the difference between the Domestic credit (% of GDP) in Algeria in 2007 and the Domestic credit (% of GDP) in Tajikistan in 2008?
Provide a succinct answer. -0.32. What is the difference between the Domestic credit (% of GDP) of Central African Republic in 2007 and the Domestic credit (% of GDP) of Ghana in 2008?
Your answer should be very brief. -9.04. What is the difference between the Domestic credit (% of GDP) of Central African Republic in 2007 and the Domestic credit (% of GDP) of Tajikistan in 2008?
Your response must be concise. -6.51. What is the difference between the Domestic credit (% of GDP) in Ghana in 2007 and the Domestic credit (% of GDP) in Tajikistan in 2008?
Make the answer very short. 1.13. What is the difference between the Domestic credit (% of GDP) in Algeria in 2007 and the Domestic credit (% of GDP) in Central African Republic in 2009?
Ensure brevity in your answer.  5.8. What is the difference between the Domestic credit (% of GDP) in Algeria in 2007 and the Domestic credit (% of GDP) in Ghana in 2009?
Your answer should be compact. -2.58. What is the difference between the Domestic credit (% of GDP) in Algeria in 2007 and the Domestic credit (% of GDP) in Tajikistan in 2009?
Provide a short and direct response. 0.71. What is the difference between the Domestic credit (% of GDP) in Central African Republic in 2007 and the Domestic credit (% of GDP) in Ghana in 2009?
Your answer should be very brief. -8.76. What is the difference between the Domestic credit (% of GDP) of Central African Republic in 2007 and the Domestic credit (% of GDP) of Tajikistan in 2009?
Provide a short and direct response. -5.48. What is the difference between the Domestic credit (% of GDP) in Ghana in 2007 and the Domestic credit (% of GDP) in Tajikistan in 2009?
Your response must be concise. 2.16. What is the difference between the Domestic credit (% of GDP) of Algeria in 2008 and the Domestic credit (% of GDP) of Central African Republic in 2009?
Your answer should be compact. 5.61. What is the difference between the Domestic credit (% of GDP) of Algeria in 2008 and the Domestic credit (% of GDP) of Ghana in 2009?
Keep it short and to the point. -2.77. What is the difference between the Domestic credit (% of GDP) of Algeria in 2008 and the Domestic credit (% of GDP) of Tajikistan in 2009?
Offer a very short reply. 0.51. What is the difference between the Domestic credit (% of GDP) of Central African Republic in 2008 and the Domestic credit (% of GDP) of Ghana in 2009?
Give a very brief answer. -8.6. What is the difference between the Domestic credit (% of GDP) in Central African Republic in 2008 and the Domestic credit (% of GDP) in Tajikistan in 2009?
Your answer should be compact. -5.32. What is the difference between the Domestic credit (% of GDP) in Ghana in 2008 and the Domestic credit (% of GDP) in Tajikistan in 2009?
Offer a terse response. 3.57. What is the average Domestic credit (% of GDP) in Algeria per year?
Ensure brevity in your answer.  12.53. What is the average Domestic credit (% of GDP) in Central African Republic per year?
Offer a very short reply. 6.7. What is the average Domestic credit (% of GDP) in Ghana per year?
Your answer should be very brief. 13.71. What is the average Domestic credit (% of GDP) of Tajikistan per year?
Your answer should be very brief. 10.1. In the year 2002, what is the difference between the Domestic credit (% of GDP) in Algeria and Domestic credit (% of GDP) in Central African Republic?
Make the answer very short. 6.32. In the year 2002, what is the difference between the Domestic credit (% of GDP) of Algeria and Domestic credit (% of GDP) of Ghana?
Ensure brevity in your answer.  0.16. In the year 2002, what is the difference between the Domestic credit (% of GDP) in Algeria and Domestic credit (% of GDP) in Tajikistan?
Offer a terse response. -0.7. In the year 2002, what is the difference between the Domestic credit (% of GDP) in Central African Republic and Domestic credit (% of GDP) in Ghana?
Your answer should be very brief. -6.16. In the year 2002, what is the difference between the Domestic credit (% of GDP) of Central African Republic and Domestic credit (% of GDP) of Tajikistan?
Make the answer very short. -7.02. In the year 2002, what is the difference between the Domestic credit (% of GDP) in Ghana and Domestic credit (% of GDP) in Tajikistan?
Ensure brevity in your answer.  -0.86. In the year 2003, what is the difference between the Domestic credit (% of GDP) of Algeria and Domestic credit (% of GDP) of Central African Republic?
Offer a terse response. 5.01. In the year 2003, what is the difference between the Domestic credit (% of GDP) of Algeria and Domestic credit (% of GDP) of Ghana?
Provide a succinct answer. -1.2. In the year 2003, what is the difference between the Domestic credit (% of GDP) of Algeria and Domestic credit (% of GDP) of Tajikistan?
Your answer should be very brief. -0.9. In the year 2003, what is the difference between the Domestic credit (% of GDP) of Central African Republic and Domestic credit (% of GDP) of Ghana?
Give a very brief answer. -6.2. In the year 2003, what is the difference between the Domestic credit (% of GDP) in Central African Republic and Domestic credit (% of GDP) in Tajikistan?
Offer a terse response. -5.91. In the year 2003, what is the difference between the Domestic credit (% of GDP) in Ghana and Domestic credit (% of GDP) in Tajikistan?
Offer a terse response. 0.29. In the year 2004, what is the difference between the Domestic credit (% of GDP) in Algeria and Domestic credit (% of GDP) in Central African Republic?
Offer a terse response. 3.81. In the year 2004, what is the difference between the Domestic credit (% of GDP) of Algeria and Domestic credit (% of GDP) of Ghana?
Keep it short and to the point. -2.09. In the year 2004, what is the difference between the Domestic credit (% of GDP) in Algeria and Domestic credit (% of GDP) in Tajikistan?
Provide a succinct answer. 6.6. In the year 2004, what is the difference between the Domestic credit (% of GDP) in Central African Republic and Domestic credit (% of GDP) in Ghana?
Offer a terse response. -5.9. In the year 2004, what is the difference between the Domestic credit (% of GDP) in Central African Republic and Domestic credit (% of GDP) in Tajikistan?
Give a very brief answer. 2.78. In the year 2004, what is the difference between the Domestic credit (% of GDP) of Ghana and Domestic credit (% of GDP) of Tajikistan?
Your answer should be very brief. 8.68. In the year 2005, what is the difference between the Domestic credit (% of GDP) in Algeria and Domestic credit (% of GDP) in Central African Republic?
Provide a short and direct response. 5.01. In the year 2005, what is the difference between the Domestic credit (% of GDP) of Algeria and Domestic credit (% of GDP) of Ghana?
Your response must be concise. -3.58. In the year 2005, what is the difference between the Domestic credit (% of GDP) in Algeria and Domestic credit (% of GDP) in Tajikistan?
Keep it short and to the point. 5.26. In the year 2005, what is the difference between the Domestic credit (% of GDP) in Central African Republic and Domestic credit (% of GDP) in Ghana?
Your answer should be compact. -8.6. In the year 2005, what is the difference between the Domestic credit (% of GDP) in Central African Republic and Domestic credit (% of GDP) in Tajikistan?
Offer a very short reply. 0.25. In the year 2005, what is the difference between the Domestic credit (% of GDP) in Ghana and Domestic credit (% of GDP) in Tajikistan?
Provide a succinct answer. 8.85. In the year 2006, what is the difference between the Domestic credit (% of GDP) in Algeria and Domestic credit (% of GDP) in Central African Republic?
Keep it short and to the point. 5.39. In the year 2006, what is the difference between the Domestic credit (% of GDP) in Algeria and Domestic credit (% of GDP) in Ghana?
Provide a short and direct response. 1.08. In the year 2006, what is the difference between the Domestic credit (% of GDP) of Algeria and Domestic credit (% of GDP) of Tajikistan?
Your answer should be very brief. 4.87. In the year 2006, what is the difference between the Domestic credit (% of GDP) in Central African Republic and Domestic credit (% of GDP) in Ghana?
Offer a terse response. -4.31. In the year 2006, what is the difference between the Domestic credit (% of GDP) of Central African Republic and Domestic credit (% of GDP) of Tajikistan?
Provide a succinct answer. -0.52. In the year 2006, what is the difference between the Domestic credit (% of GDP) in Ghana and Domestic credit (% of GDP) in Tajikistan?
Keep it short and to the point. 3.79. In the year 2007, what is the difference between the Domestic credit (% of GDP) in Algeria and Domestic credit (% of GDP) in Central African Republic?
Provide a succinct answer. 6.19. In the year 2007, what is the difference between the Domestic credit (% of GDP) in Algeria and Domestic credit (% of GDP) in Ghana?
Offer a very short reply. -1.45. In the year 2007, what is the difference between the Domestic credit (% of GDP) in Algeria and Domestic credit (% of GDP) in Tajikistan?
Keep it short and to the point. 0.84. In the year 2007, what is the difference between the Domestic credit (% of GDP) in Central African Republic and Domestic credit (% of GDP) in Ghana?
Make the answer very short. -7.63. In the year 2007, what is the difference between the Domestic credit (% of GDP) of Central African Republic and Domestic credit (% of GDP) of Tajikistan?
Your answer should be very brief. -5.34. In the year 2007, what is the difference between the Domestic credit (% of GDP) of Ghana and Domestic credit (% of GDP) of Tajikistan?
Your answer should be very brief. 2.29. In the year 2008, what is the difference between the Domestic credit (% of GDP) of Algeria and Domestic credit (% of GDP) of Central African Republic?
Ensure brevity in your answer.  5.83. In the year 2008, what is the difference between the Domestic credit (% of GDP) in Algeria and Domestic credit (% of GDP) in Ghana?
Your answer should be compact. -3.05. In the year 2008, what is the difference between the Domestic credit (% of GDP) in Algeria and Domestic credit (% of GDP) in Tajikistan?
Provide a short and direct response. -0.52. In the year 2008, what is the difference between the Domestic credit (% of GDP) in Central African Republic and Domestic credit (% of GDP) in Ghana?
Make the answer very short. -8.88. In the year 2008, what is the difference between the Domestic credit (% of GDP) in Central African Republic and Domestic credit (% of GDP) in Tajikistan?
Your answer should be compact. -6.35. In the year 2008, what is the difference between the Domestic credit (% of GDP) of Ghana and Domestic credit (% of GDP) of Tajikistan?
Provide a short and direct response. 2.53. In the year 2009, what is the difference between the Domestic credit (% of GDP) of Algeria and Domestic credit (% of GDP) of Central African Republic?
Keep it short and to the point. 9.08. In the year 2009, what is the difference between the Domestic credit (% of GDP) in Algeria and Domestic credit (% of GDP) in Ghana?
Provide a succinct answer. 0.7. In the year 2009, what is the difference between the Domestic credit (% of GDP) in Algeria and Domestic credit (% of GDP) in Tajikistan?
Keep it short and to the point. 3.98. In the year 2009, what is the difference between the Domestic credit (% of GDP) in Central African Republic and Domestic credit (% of GDP) in Ghana?
Give a very brief answer. -8.37. In the year 2009, what is the difference between the Domestic credit (% of GDP) of Central African Republic and Domestic credit (% of GDP) of Tajikistan?
Provide a succinct answer. -5.09. In the year 2009, what is the difference between the Domestic credit (% of GDP) of Ghana and Domestic credit (% of GDP) of Tajikistan?
Provide a short and direct response. 3.28. What is the ratio of the Domestic credit (% of GDP) in Algeria in 2002 to that in 2003?
Offer a very short reply. 1.09. What is the ratio of the Domestic credit (% of GDP) in Central African Republic in 2002 to that in 2003?
Your answer should be compact. 0.94. What is the ratio of the Domestic credit (% of GDP) in Ghana in 2002 to that in 2003?
Your response must be concise. 0.97. What is the ratio of the Domestic credit (% of GDP) of Tajikistan in 2002 to that in 2003?
Make the answer very short. 1.06. What is the ratio of the Domestic credit (% of GDP) in Algeria in 2002 to that in 2004?
Provide a short and direct response. 1.11. What is the ratio of the Domestic credit (% of GDP) in Central African Republic in 2002 to that in 2004?
Give a very brief answer. 0.82. What is the ratio of the Domestic credit (% of GDP) of Ghana in 2002 to that in 2004?
Your answer should be very brief. 0.92. What is the ratio of the Domestic credit (% of GDP) of Tajikistan in 2002 to that in 2004?
Offer a very short reply. 2.94. What is the ratio of the Domestic credit (% of GDP) of Algeria in 2002 to that in 2005?
Your response must be concise. 1.03. What is the ratio of the Domestic credit (% of GDP) in Central African Republic in 2002 to that in 2005?
Keep it short and to the point. 0.85. What is the ratio of the Domestic credit (% of GDP) in Ghana in 2002 to that in 2005?
Make the answer very short. 0.78. What is the ratio of the Domestic credit (% of GDP) of Tajikistan in 2002 to that in 2005?
Give a very brief answer. 1.95. What is the ratio of the Domestic credit (% of GDP) of Algeria in 2002 to that in 2006?
Your answer should be very brief. 1.01. What is the ratio of the Domestic credit (% of GDP) of Central African Republic in 2002 to that in 2006?
Make the answer very short. 0.87. What is the ratio of the Domestic credit (% of GDP) of Ghana in 2002 to that in 2006?
Give a very brief answer. 1.09. What is the ratio of the Domestic credit (% of GDP) in Tajikistan in 2002 to that in 2006?
Offer a very short reply. 1.78. What is the ratio of the Domestic credit (% of GDP) in Algeria in 2002 to that in 2007?
Ensure brevity in your answer.  0.94. What is the ratio of the Domestic credit (% of GDP) of Central African Republic in 2002 to that in 2007?
Offer a terse response. 0.86. What is the ratio of the Domestic credit (% of GDP) of Ghana in 2002 to that in 2007?
Give a very brief answer. 0.83. What is the ratio of the Domestic credit (% of GDP) of Tajikistan in 2002 to that in 2007?
Your answer should be compact. 1.06. What is the ratio of the Domestic credit (% of GDP) of Algeria in 2002 to that in 2008?
Make the answer very short. 0.95. What is the ratio of the Domestic credit (% of GDP) of Central African Republic in 2002 to that in 2008?
Make the answer very short. 0.84. What is the ratio of the Domestic credit (% of GDP) in Ghana in 2002 to that in 2008?
Offer a terse response. 0.76. What is the ratio of the Domestic credit (% of GDP) in Tajikistan in 2002 to that in 2008?
Your answer should be very brief. 0.97. What is the ratio of the Domestic credit (% of GDP) in Algeria in 2002 to that in 2009?
Give a very brief answer. 0.75. What is the ratio of the Domestic credit (% of GDP) of Central African Republic in 2002 to that in 2009?
Make the answer very short. 0.81. What is the ratio of the Domestic credit (% of GDP) in Ghana in 2002 to that in 2009?
Give a very brief answer. 0.77. What is the ratio of the Domestic credit (% of GDP) in Tajikistan in 2002 to that in 2009?
Provide a succinct answer. 1.05. What is the ratio of the Domestic credit (% of GDP) in Algeria in 2003 to that in 2004?
Keep it short and to the point. 1.02. What is the ratio of the Domestic credit (% of GDP) in Central African Republic in 2003 to that in 2004?
Offer a terse response. 0.86. What is the ratio of the Domestic credit (% of GDP) in Ghana in 2003 to that in 2004?
Give a very brief answer. 0.95. What is the ratio of the Domestic credit (% of GDP) in Tajikistan in 2003 to that in 2004?
Give a very brief answer. 2.76. What is the ratio of the Domestic credit (% of GDP) in Algeria in 2003 to that in 2005?
Your response must be concise. 0.94. What is the ratio of the Domestic credit (% of GDP) of Central African Republic in 2003 to that in 2005?
Your answer should be compact. 0.91. What is the ratio of the Domestic credit (% of GDP) in Ghana in 2003 to that in 2005?
Make the answer very short. 0.8. What is the ratio of the Domestic credit (% of GDP) of Tajikistan in 2003 to that in 2005?
Make the answer very short. 1.84. What is the ratio of the Domestic credit (% of GDP) of Algeria in 2003 to that in 2006?
Offer a very short reply. 0.93. What is the ratio of the Domestic credit (% of GDP) in Central African Republic in 2003 to that in 2006?
Ensure brevity in your answer.  0.92. What is the ratio of the Domestic credit (% of GDP) of Ghana in 2003 to that in 2006?
Keep it short and to the point. 1.12. What is the ratio of the Domestic credit (% of GDP) of Tajikistan in 2003 to that in 2006?
Make the answer very short. 1.67. What is the ratio of the Domestic credit (% of GDP) in Algeria in 2003 to that in 2007?
Offer a terse response. 0.86. What is the ratio of the Domestic credit (% of GDP) of Central African Republic in 2003 to that in 2007?
Keep it short and to the point. 0.91. What is the ratio of the Domestic credit (% of GDP) of Ghana in 2003 to that in 2007?
Offer a terse response. 0.86. What is the ratio of the Domestic credit (% of GDP) in Tajikistan in 2003 to that in 2007?
Your response must be concise. 1. What is the ratio of the Domestic credit (% of GDP) of Algeria in 2003 to that in 2008?
Your response must be concise. 0.88. What is the ratio of the Domestic credit (% of GDP) in Central African Republic in 2003 to that in 2008?
Provide a succinct answer. 0.89. What is the ratio of the Domestic credit (% of GDP) of Ghana in 2003 to that in 2008?
Make the answer very short. 0.78. What is the ratio of the Domestic credit (% of GDP) of Tajikistan in 2003 to that in 2008?
Make the answer very short. 0.91. What is the ratio of the Domestic credit (% of GDP) in Algeria in 2003 to that in 2009?
Offer a very short reply. 0.69. What is the ratio of the Domestic credit (% of GDP) in Central African Republic in 2003 to that in 2009?
Give a very brief answer. 0.86. What is the ratio of the Domestic credit (% of GDP) of Ghana in 2003 to that in 2009?
Offer a very short reply. 0.8. What is the ratio of the Domestic credit (% of GDP) in Tajikistan in 2003 to that in 2009?
Offer a very short reply. 0.99. What is the ratio of the Domestic credit (% of GDP) in Algeria in 2004 to that in 2005?
Ensure brevity in your answer.  0.93. What is the ratio of the Domestic credit (% of GDP) of Central African Republic in 2004 to that in 2005?
Your answer should be very brief. 1.05. What is the ratio of the Domestic credit (% of GDP) of Ghana in 2004 to that in 2005?
Offer a very short reply. 0.85. What is the ratio of the Domestic credit (% of GDP) of Tajikistan in 2004 to that in 2005?
Your answer should be compact. 0.66. What is the ratio of the Domestic credit (% of GDP) in Algeria in 2004 to that in 2006?
Offer a very short reply. 0.91. What is the ratio of the Domestic credit (% of GDP) of Central African Republic in 2004 to that in 2006?
Your answer should be very brief. 1.07. What is the ratio of the Domestic credit (% of GDP) of Ghana in 2004 to that in 2006?
Make the answer very short. 1.19. What is the ratio of the Domestic credit (% of GDP) in Tajikistan in 2004 to that in 2006?
Your answer should be very brief. 0.61. What is the ratio of the Domestic credit (% of GDP) of Algeria in 2004 to that in 2007?
Provide a succinct answer. 0.85. What is the ratio of the Domestic credit (% of GDP) of Central African Republic in 2004 to that in 2007?
Make the answer very short. 1.06. What is the ratio of the Domestic credit (% of GDP) in Ghana in 2004 to that in 2007?
Offer a very short reply. 0.91. What is the ratio of the Domestic credit (% of GDP) in Tajikistan in 2004 to that in 2007?
Provide a succinct answer. 0.36. What is the ratio of the Domestic credit (% of GDP) of Algeria in 2004 to that in 2008?
Give a very brief answer. 0.86. What is the ratio of the Domestic credit (% of GDP) of Central African Republic in 2004 to that in 2008?
Your answer should be very brief. 1.03. What is the ratio of the Domestic credit (% of GDP) of Ghana in 2004 to that in 2008?
Provide a succinct answer. 0.82. What is the ratio of the Domestic credit (% of GDP) of Tajikistan in 2004 to that in 2008?
Your answer should be compact. 0.33. What is the ratio of the Domestic credit (% of GDP) of Algeria in 2004 to that in 2009?
Provide a succinct answer. 0.68. What is the ratio of the Domestic credit (% of GDP) of Central African Republic in 2004 to that in 2009?
Give a very brief answer. 1. What is the ratio of the Domestic credit (% of GDP) in Ghana in 2004 to that in 2009?
Your answer should be compact. 0.84. What is the ratio of the Domestic credit (% of GDP) in Tajikistan in 2004 to that in 2009?
Your answer should be very brief. 0.36. What is the ratio of the Domestic credit (% of GDP) in Algeria in 2005 to that in 2006?
Make the answer very short. 0.98. What is the ratio of the Domestic credit (% of GDP) of Central African Republic in 2005 to that in 2006?
Your answer should be compact. 1.02. What is the ratio of the Domestic credit (% of GDP) in Ghana in 2005 to that in 2006?
Ensure brevity in your answer.  1.4. What is the ratio of the Domestic credit (% of GDP) of Tajikistan in 2005 to that in 2006?
Your response must be concise. 0.91. What is the ratio of the Domestic credit (% of GDP) in Algeria in 2005 to that in 2007?
Provide a short and direct response. 0.91. What is the ratio of the Domestic credit (% of GDP) of Central African Republic in 2005 to that in 2007?
Your answer should be compact. 1.01. What is the ratio of the Domestic credit (% of GDP) of Ghana in 2005 to that in 2007?
Provide a short and direct response. 1.07. What is the ratio of the Domestic credit (% of GDP) in Tajikistan in 2005 to that in 2007?
Your answer should be very brief. 0.54. What is the ratio of the Domestic credit (% of GDP) in Algeria in 2005 to that in 2008?
Make the answer very short. 0.93. What is the ratio of the Domestic credit (% of GDP) of Ghana in 2005 to that in 2008?
Ensure brevity in your answer.  0.97. What is the ratio of the Domestic credit (% of GDP) in Tajikistan in 2005 to that in 2008?
Provide a short and direct response. 0.5. What is the ratio of the Domestic credit (% of GDP) of Algeria in 2005 to that in 2009?
Your answer should be very brief. 0.73. What is the ratio of the Domestic credit (% of GDP) in Central African Republic in 2005 to that in 2009?
Your answer should be compact. 0.95. What is the ratio of the Domestic credit (% of GDP) of Tajikistan in 2005 to that in 2009?
Ensure brevity in your answer.  0.54. What is the ratio of the Domestic credit (% of GDP) in Algeria in 2006 to that in 2007?
Provide a short and direct response. 0.93. What is the ratio of the Domestic credit (% of GDP) in Ghana in 2006 to that in 2007?
Your answer should be compact. 0.76. What is the ratio of the Domestic credit (% of GDP) of Tajikistan in 2006 to that in 2007?
Provide a succinct answer. 0.6. What is the ratio of the Domestic credit (% of GDP) in Algeria in 2006 to that in 2008?
Offer a terse response. 0.95. What is the ratio of the Domestic credit (% of GDP) in Central African Republic in 2006 to that in 2008?
Keep it short and to the point. 0.97. What is the ratio of the Domestic credit (% of GDP) of Ghana in 2006 to that in 2008?
Offer a very short reply. 0.7. What is the ratio of the Domestic credit (% of GDP) in Tajikistan in 2006 to that in 2008?
Provide a short and direct response. 0.54. What is the ratio of the Domestic credit (% of GDP) of Algeria in 2006 to that in 2009?
Give a very brief answer. 0.74. What is the ratio of the Domestic credit (% of GDP) in Central African Republic in 2006 to that in 2009?
Keep it short and to the point. 0.94. What is the ratio of the Domestic credit (% of GDP) in Ghana in 2006 to that in 2009?
Ensure brevity in your answer.  0.71. What is the ratio of the Domestic credit (% of GDP) in Tajikistan in 2006 to that in 2009?
Ensure brevity in your answer.  0.59. What is the ratio of the Domestic credit (% of GDP) of Central African Republic in 2007 to that in 2008?
Your answer should be very brief. 0.98. What is the ratio of the Domestic credit (% of GDP) of Ghana in 2007 to that in 2008?
Make the answer very short. 0.91. What is the ratio of the Domestic credit (% of GDP) in Tajikistan in 2007 to that in 2008?
Give a very brief answer. 0.91. What is the ratio of the Domestic credit (% of GDP) of Algeria in 2007 to that in 2009?
Offer a very short reply. 0.8. What is the ratio of the Domestic credit (% of GDP) of Central African Republic in 2007 to that in 2009?
Make the answer very short. 0.95. What is the ratio of the Domestic credit (% of GDP) in Ghana in 2007 to that in 2009?
Make the answer very short. 0.93. What is the ratio of the Domestic credit (% of GDP) in Algeria in 2008 to that in 2009?
Ensure brevity in your answer.  0.79. What is the ratio of the Domestic credit (% of GDP) of Central African Republic in 2008 to that in 2009?
Your answer should be very brief. 0.97. What is the ratio of the Domestic credit (% of GDP) of Ghana in 2008 to that in 2009?
Keep it short and to the point. 1.02. What is the ratio of the Domestic credit (% of GDP) in Tajikistan in 2008 to that in 2009?
Your answer should be very brief. 1.08. What is the difference between the highest and the second highest Domestic credit (% of GDP) in Algeria?
Ensure brevity in your answer.  3.28. What is the difference between the highest and the second highest Domestic credit (% of GDP) of Central African Republic?
Make the answer very short. 0.01. What is the difference between the highest and the second highest Domestic credit (% of GDP) of Ghana?
Your answer should be compact. 0.28. What is the difference between the highest and the second highest Domestic credit (% of GDP) of Tajikistan?
Offer a very short reply. 0.43. What is the difference between the highest and the lowest Domestic credit (% of GDP) of Algeria?
Offer a terse response. 5.27. What is the difference between the highest and the lowest Domestic credit (% of GDP) of Central African Republic?
Ensure brevity in your answer.  1.33. What is the difference between the highest and the lowest Domestic credit (% of GDP) of Ghana?
Your answer should be compact. 4.81. What is the difference between the highest and the lowest Domestic credit (% of GDP) in Tajikistan?
Ensure brevity in your answer.  8.92. 